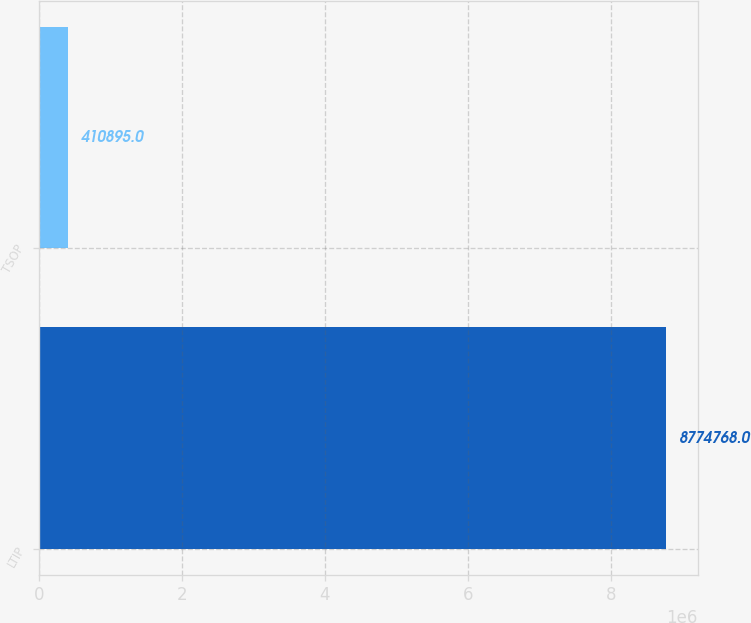<chart> <loc_0><loc_0><loc_500><loc_500><bar_chart><fcel>LTIP<fcel>TSOP<nl><fcel>8.77477e+06<fcel>410895<nl></chart> 